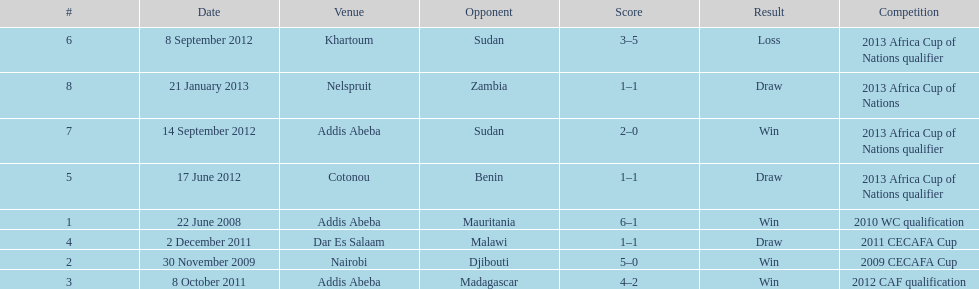How long in years down this table cover? 5. 